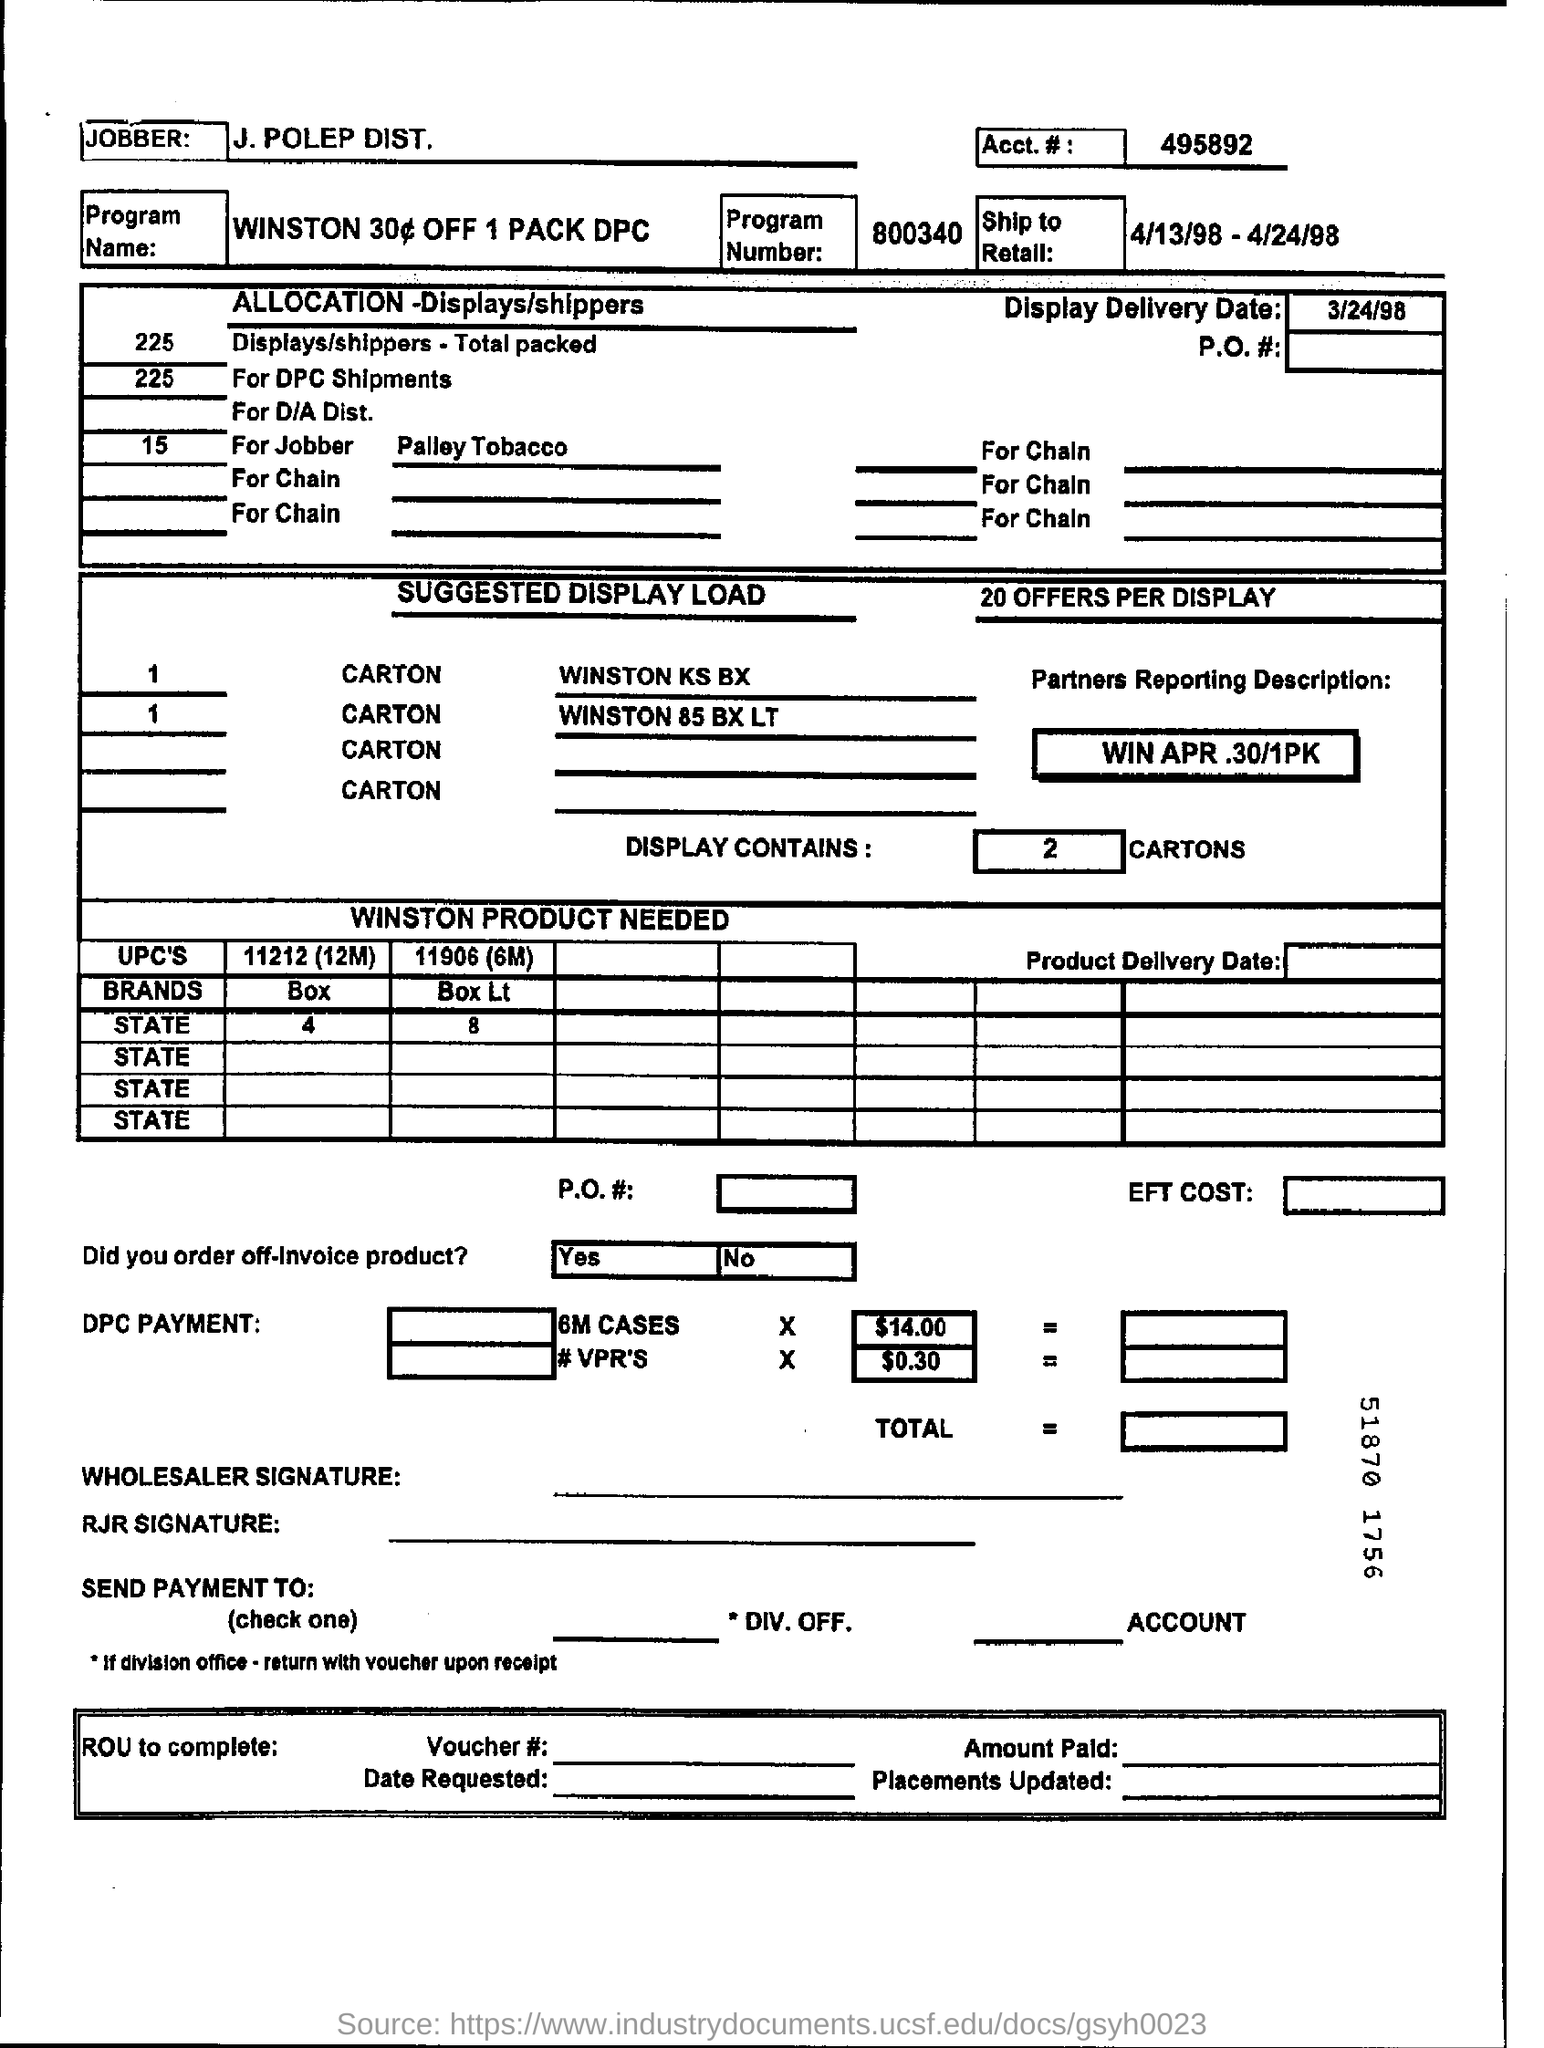Who is the jobber?
Ensure brevity in your answer.  J. Polep Dist. What is the program number?
Your answer should be very brief. 800340. When is the Display Delivery Date?
Ensure brevity in your answer.  3/24/98. How many cartons does display contain?
Your answer should be very brief. 2. 